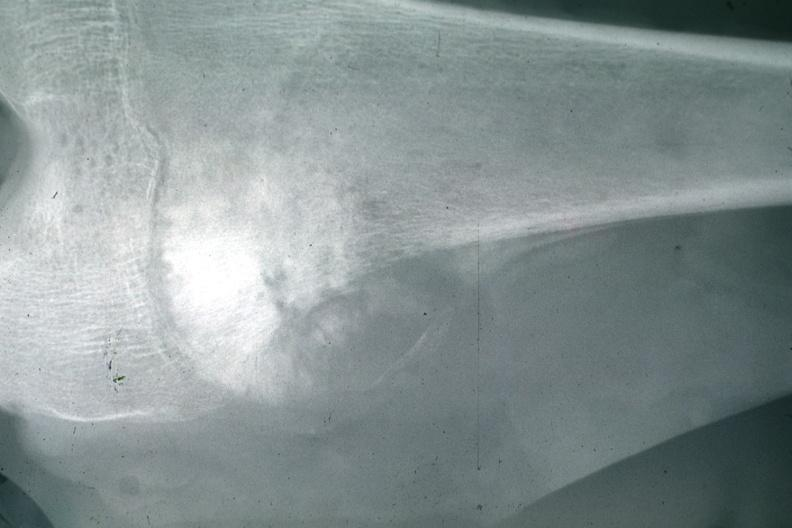does this image show x-ray typical lesion?
Answer the question using a single word or phrase. Yes 